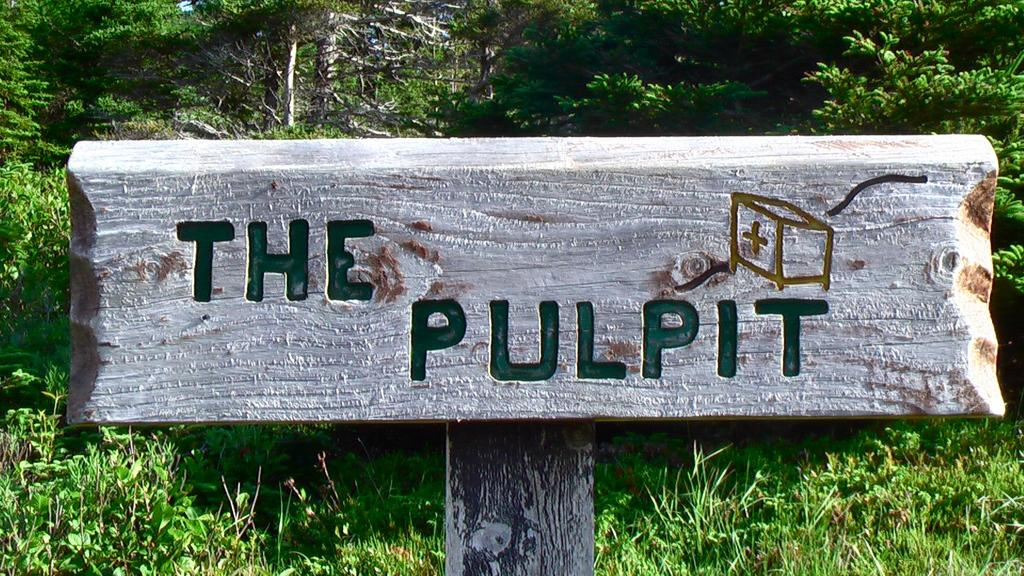What is the main object in the center of the image? There is a wooden board in the center of the image. What can be seen in the background of the image? There are trees in the background of the image. What type of vegetation is at the bottom of the image? There is grass at the bottom of the image. What type of soup is being prepared on the wooden board in the image? There is no soup or any indication of food preparation in the image; it only features a wooden board and the surrounding environment. 